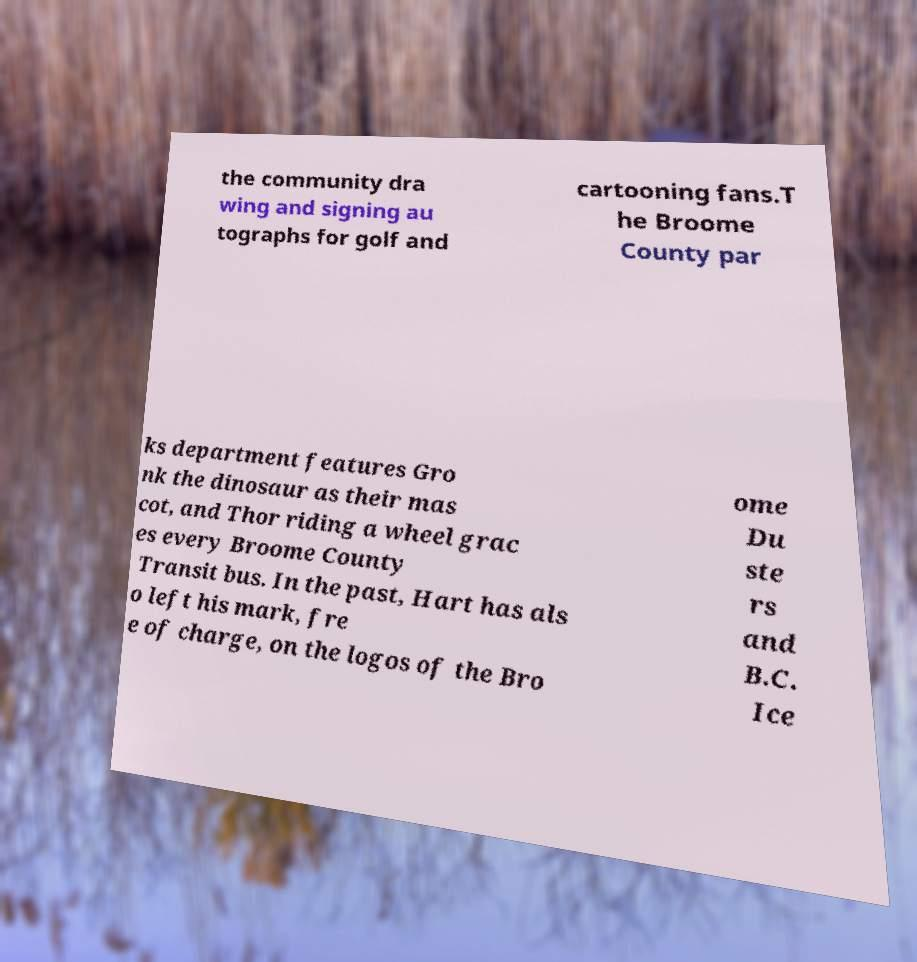For documentation purposes, I need the text within this image transcribed. Could you provide that? the community dra wing and signing au tographs for golf and cartooning fans.T he Broome County par ks department features Gro nk the dinosaur as their mas cot, and Thor riding a wheel grac es every Broome County Transit bus. In the past, Hart has als o left his mark, fre e of charge, on the logos of the Bro ome Du ste rs and B.C. Ice 